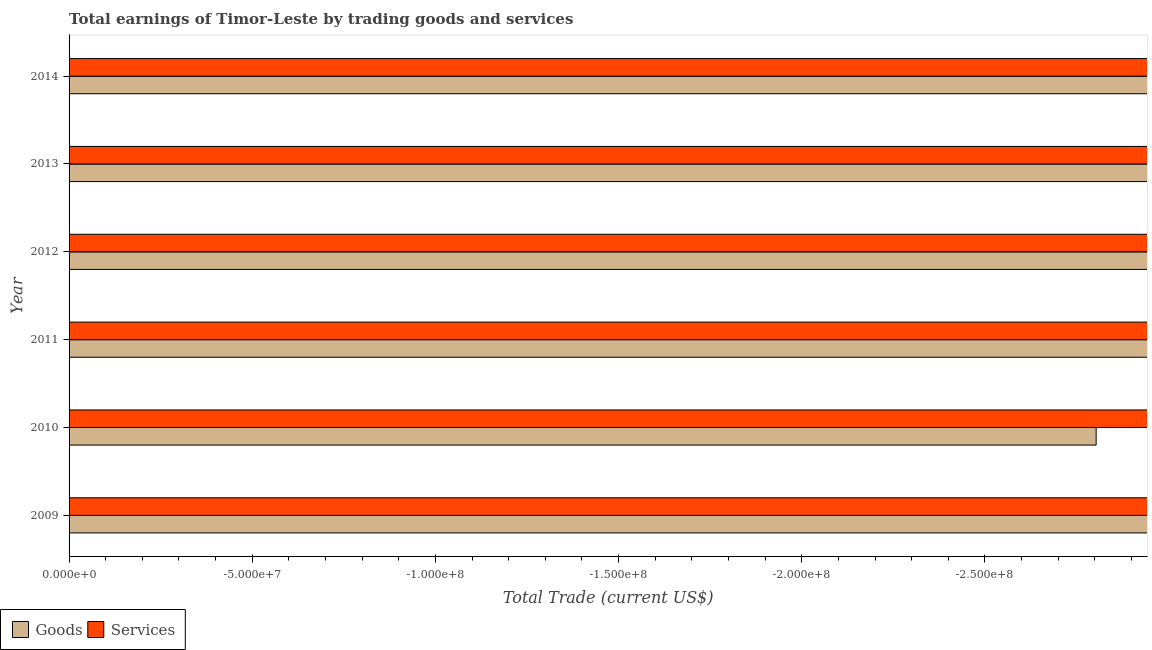How many different coloured bars are there?
Your answer should be very brief. 0. Are the number of bars on each tick of the Y-axis equal?
Offer a terse response. Yes. How many bars are there on the 1st tick from the top?
Provide a short and direct response. 0. How many bars are there on the 1st tick from the bottom?
Give a very brief answer. 0. Across all years, what is the minimum amount earned by trading goods?
Keep it short and to the point. 0. What is the total amount earned by trading goods in the graph?
Your answer should be compact. 0. What is the difference between the amount earned by trading services in 2010 and the amount earned by trading goods in 2013?
Offer a terse response. 0. What is the average amount earned by trading services per year?
Offer a terse response. 0. Are all the bars in the graph horizontal?
Offer a terse response. Yes. How many years are there in the graph?
Ensure brevity in your answer.  6. What is the difference between two consecutive major ticks on the X-axis?
Offer a terse response. 5.00e+07. Are the values on the major ticks of X-axis written in scientific E-notation?
Give a very brief answer. Yes. Does the graph contain any zero values?
Your response must be concise. Yes. Where does the legend appear in the graph?
Provide a succinct answer. Bottom left. What is the title of the graph?
Keep it short and to the point. Total earnings of Timor-Leste by trading goods and services. What is the label or title of the X-axis?
Provide a succinct answer. Total Trade (current US$). What is the Total Trade (current US$) in Services in 2011?
Your answer should be very brief. 0. What is the Total Trade (current US$) of Goods in 2013?
Provide a short and direct response. 0. What is the Total Trade (current US$) of Services in 2013?
Keep it short and to the point. 0. What is the total Total Trade (current US$) of Services in the graph?
Keep it short and to the point. 0. What is the average Total Trade (current US$) of Goods per year?
Provide a short and direct response. 0. 